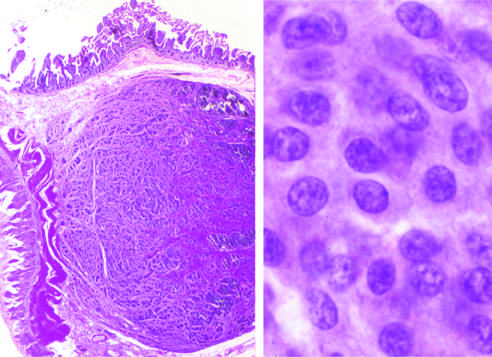what shows the bland cytology that typifies neuroendocrine tumors?
Answer the question using a single word or phrase. High magnification 